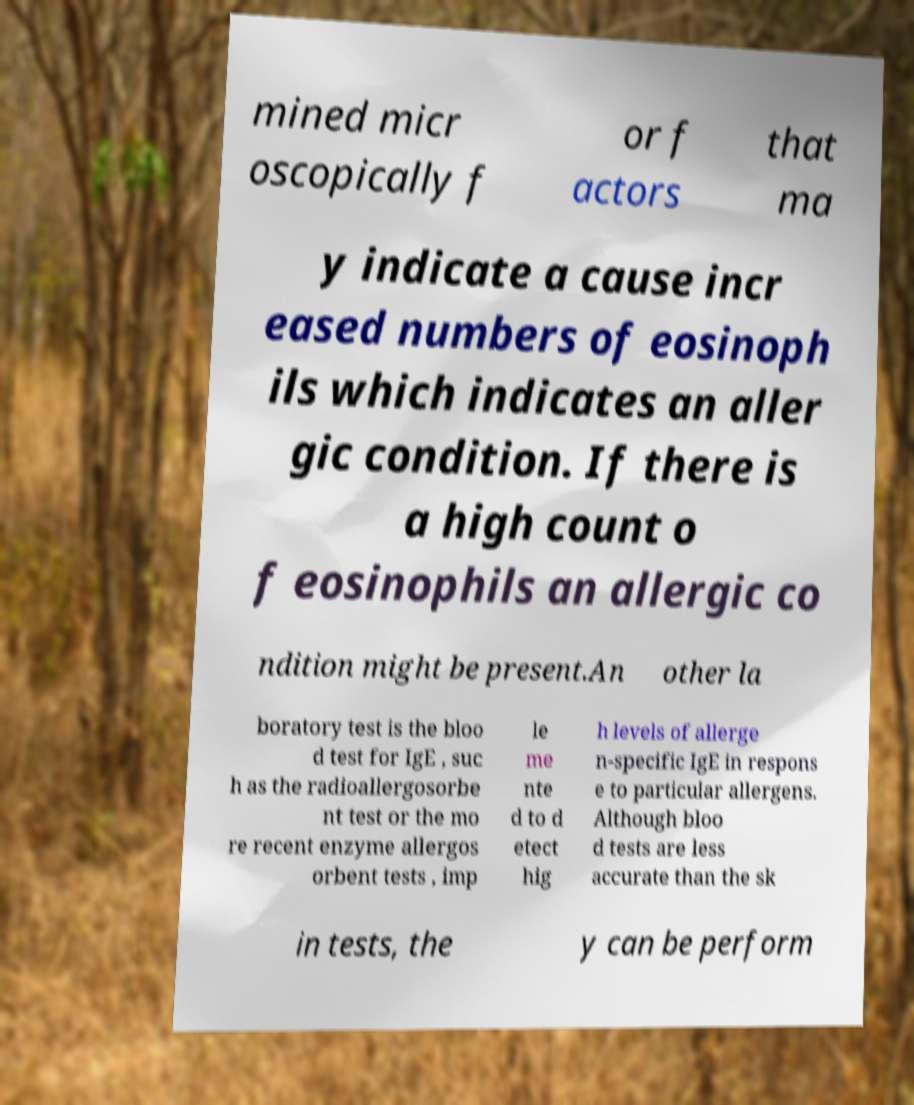What messages or text are displayed in this image? I need them in a readable, typed format. mined micr oscopically f or f actors that ma y indicate a cause incr eased numbers of eosinoph ils which indicates an aller gic condition. If there is a high count o f eosinophils an allergic co ndition might be present.An other la boratory test is the bloo d test for IgE , suc h as the radioallergosorbe nt test or the mo re recent enzyme allergos orbent tests , imp le me nte d to d etect hig h levels of allerge n-specific IgE in respons e to particular allergens. Although bloo d tests are less accurate than the sk in tests, the y can be perform 